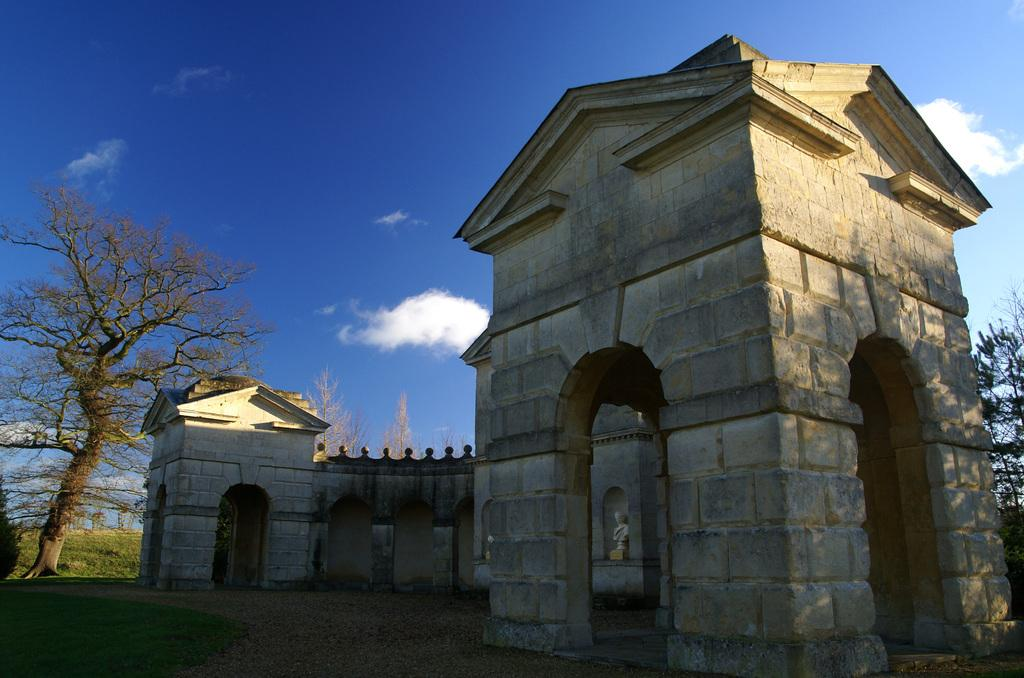What is the main subject in the middle of the image? There is a statue or a building in the middle of the image. What type of vegetation is present on either side of the image? There are trees on either side of the image. What is the condition of the sky in the image? The sky is cloudy and visible at the top of the image. What type of garden can be seen in the image? There is no garden present in the image; it features a statue or a building with trees on either side. How does the digestion process appear in the image? There is no reference to digestion in the image; it focuses on a statue or a building, trees, and the sky. 